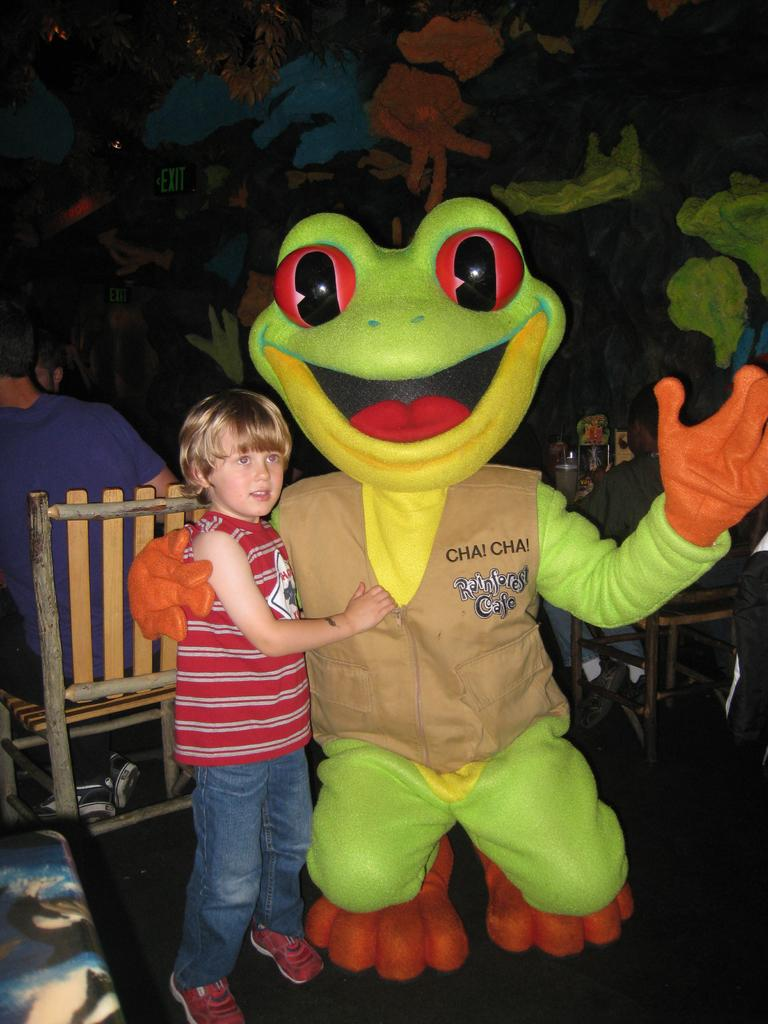What is the main subject in the foreground of the picture? There is a kid in the foreground of the picture. What can be seen beside the kid? There is a mascot beside the kid. What is visible in the background of the picture? There are people, chairs, and a table visible in the background of the picture. What is the appearance of the wall in the background? The wall in the background is painted with different symbols. Can you buy oranges at the market in the image? There is no mention of a market or oranges in the image. 